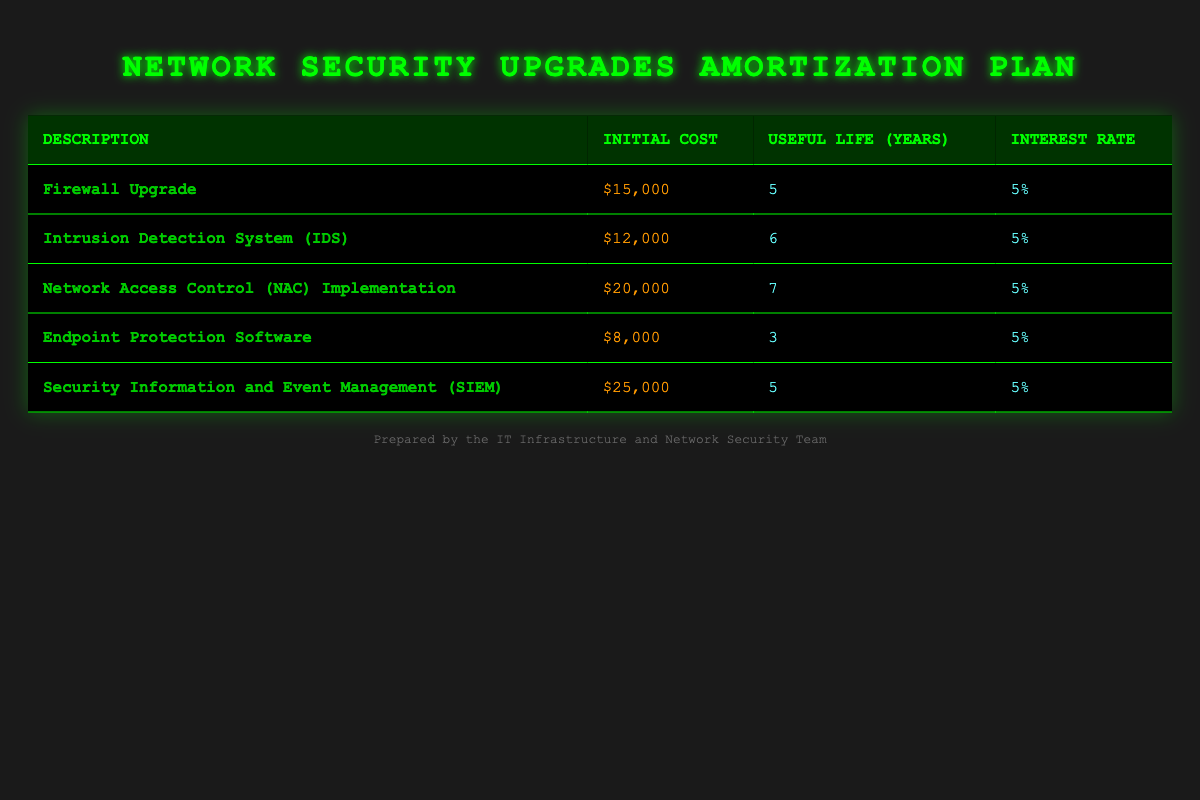What is the initial cost of the Firewall Upgrade? The initial cost of the Firewall Upgrade is listed in the table under "Initial Cost," which corresponds to $15,000.
Answer: $15,000 How many years is the useful life of the Network Access Control (NAC) Implementation? The useful life for the Network Access Control (NAC) Implementation is directly provided in the table, showing a duration of 7 years.
Answer: 7 years Is the interest rate for the Endpoint Protection Software greater than 5%? The interest rate for the Endpoint Protection Software is given as 5%, so it is not greater than 5%. Therefore, the answer is false.
Answer: No What is the total initial cost of all listed capital expenditures? To find the total initial cost, we sum all individual costs: $15,000 + $12,000 + $20,000 + $8,000 + $25,000 = $80,000.
Answer: $80,000 Which capital expenditure has the shortest useful life, and what is that duration? By examining the useful life column, we see that Endpoint Protection Software has the shortest useful life of 3 years.
Answer: Endpoint Protection Software, 3 years What is the average useful life of all the capital expenditures? To calculate the average useful life, we first sum the useful lives: 5 + 6 + 7 + 3 + 5 = 26 years. Then we divide by the number of expenditures, which is 5: 26/5 = 5.2 years.
Answer: 5.2 years Is there more than one capital expenditure with a useful life of 5 years? Checking the useful life column reveals that there are two entries (Firewall Upgrade and SIEM) with a useful life of 5 years, so the answer is yes.
Answer: Yes How much more is the initial cost of the Security Information and Event Management (SIEM) compared to the Intrusion Detection System (IDS)? The initial cost of SIEM is $25,000 and IDS is $12,000. Subtracting gives us $25,000 - $12,000 = $13,000 more for SIEM.
Answer: $13,000 What is the total interest paid over the useful life of the Firewall Upgrade? To find the total interest, we first calculate the annual interest using the formula: Interest = Principal * Rate = $15,000 * 5% = $750 annually. Over 5 years, this amounts to $750 * 5 = $3,750.
Answer: $3,750 